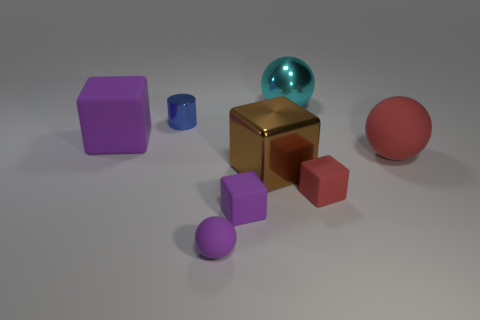Add 1 green matte cylinders. How many objects exist? 9 Subtract all cylinders. How many objects are left? 7 Add 6 brown metallic objects. How many brown metallic objects exist? 7 Subtract 1 cyan spheres. How many objects are left? 7 Subtract all big purple rubber blocks. Subtract all cyan balls. How many objects are left? 6 Add 6 large purple matte cubes. How many large purple matte cubes are left? 7 